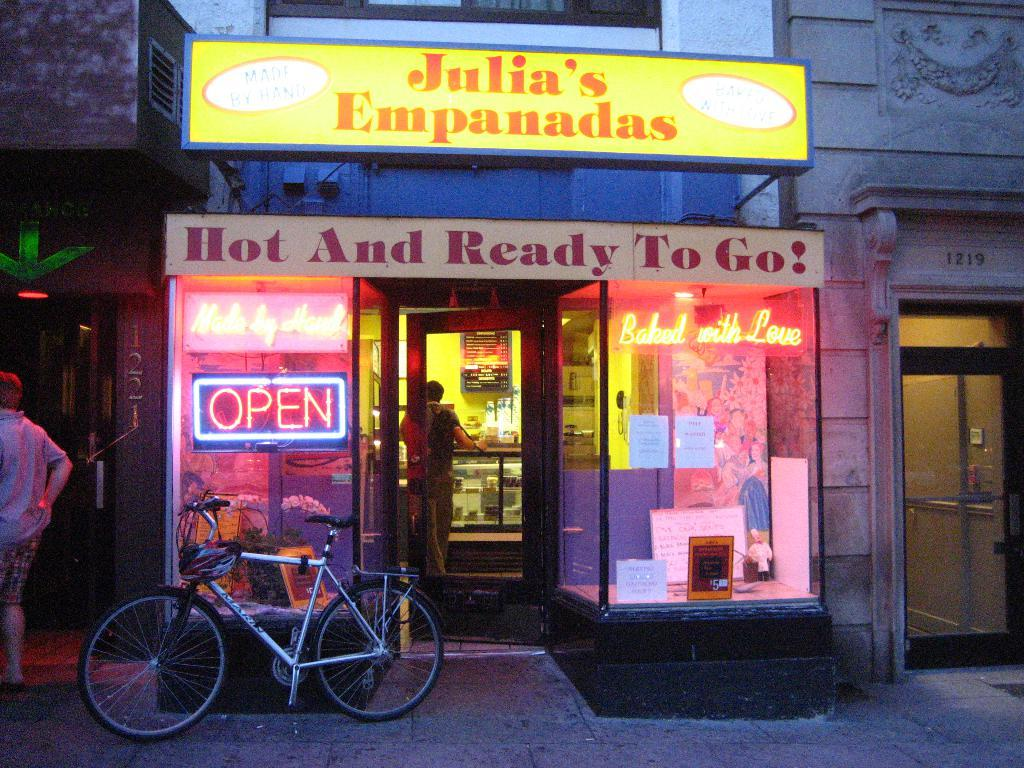What type of structure can be seen in the image? There is a building in the image. What are the name boards used for in the image? The name boards are used for identification or direction in the image. What mode of transportation is visible in the image? There is a bicycle in the image. What safety accessory is visible in the image? A helmet is visible in the image. What type of visual aids are present in the image? There are posters in the image. What type of play items are present in the image? Toys are present in the image. How many people are standing in the image? There are two people standing in the image. Can you describe the unspecified objects in the image? Unfortunately, the facts provided do not specify the nature of the unspecified objects in the image. How many children are playing with the toys in the image? There is no mention of children in the image, only toys and two people standing. What type of furniture is visible in the image? There is no furniture visible in the image. How many knots are tied on the bicycle in the image? There is no mention of knots in the image; only a bicycle and a helmet are mentioned. 